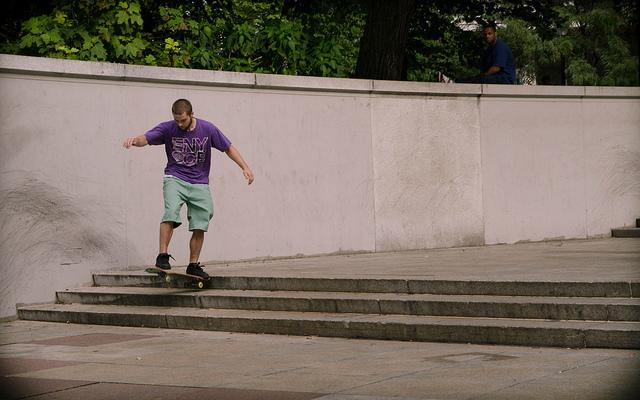Does this man have any pens on him?
Quick response, please. No. What is the man standing on?
Concise answer only. Skateboard. What type of place is the man skateboarding?
Give a very brief answer. Stairs. What is the mad doing?
Keep it brief. Skateboarding. Is the man on the stairs?
Keep it brief. Yes. What color shirt is the man sitting down wearing?
Give a very brief answer. Blue. What's the name of that trick?
Quick response, please. Jump. What is on the stairs?
Concise answer only. Skateboarder. 